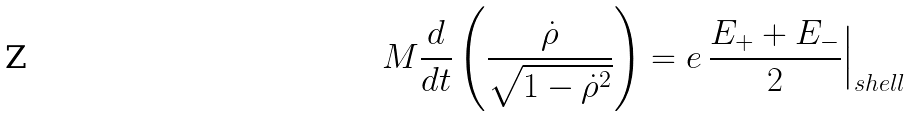<formula> <loc_0><loc_0><loc_500><loc_500>M \frac { d } { d t } \left ( \frac { \dot { \rho } } { \sqrt { 1 - { \dot { \rho } } ^ { 2 } } } \right ) = e \, \frac { E _ { + } + E _ { - } } { 2 } \Big | _ { s h e l l }</formula> 